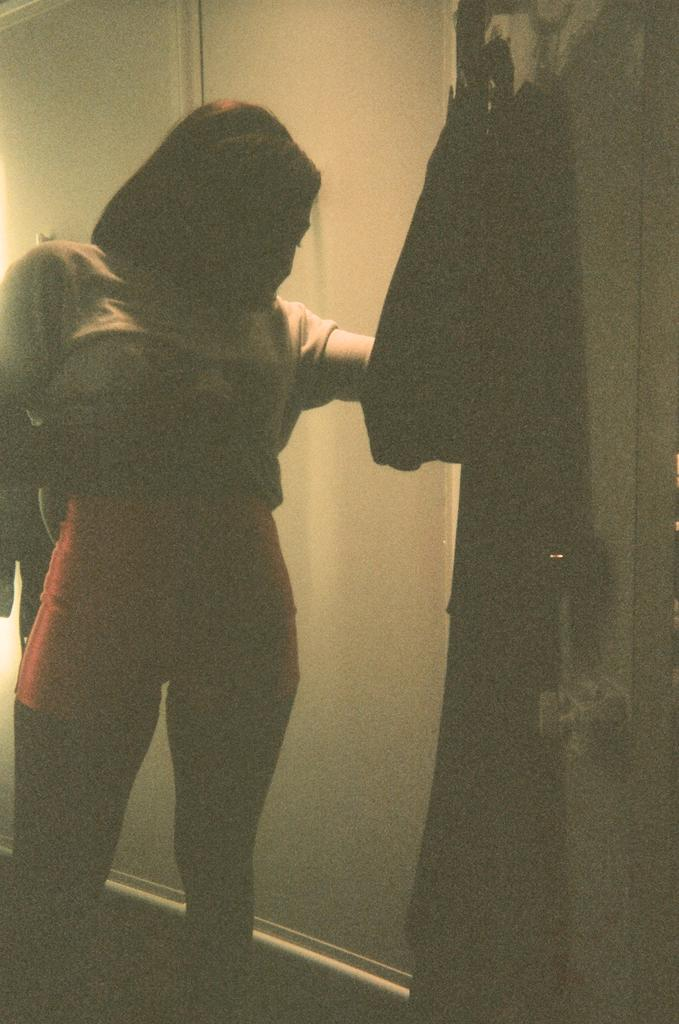What is the main subject in the image? There is a lady standing in the image. Can you describe the objects hanging on the wall in the image? There are objects hanging on a wall on the right side of the image. What type of notebook is the donkey holding in the image? There is no donkey or notebook present in the image. 